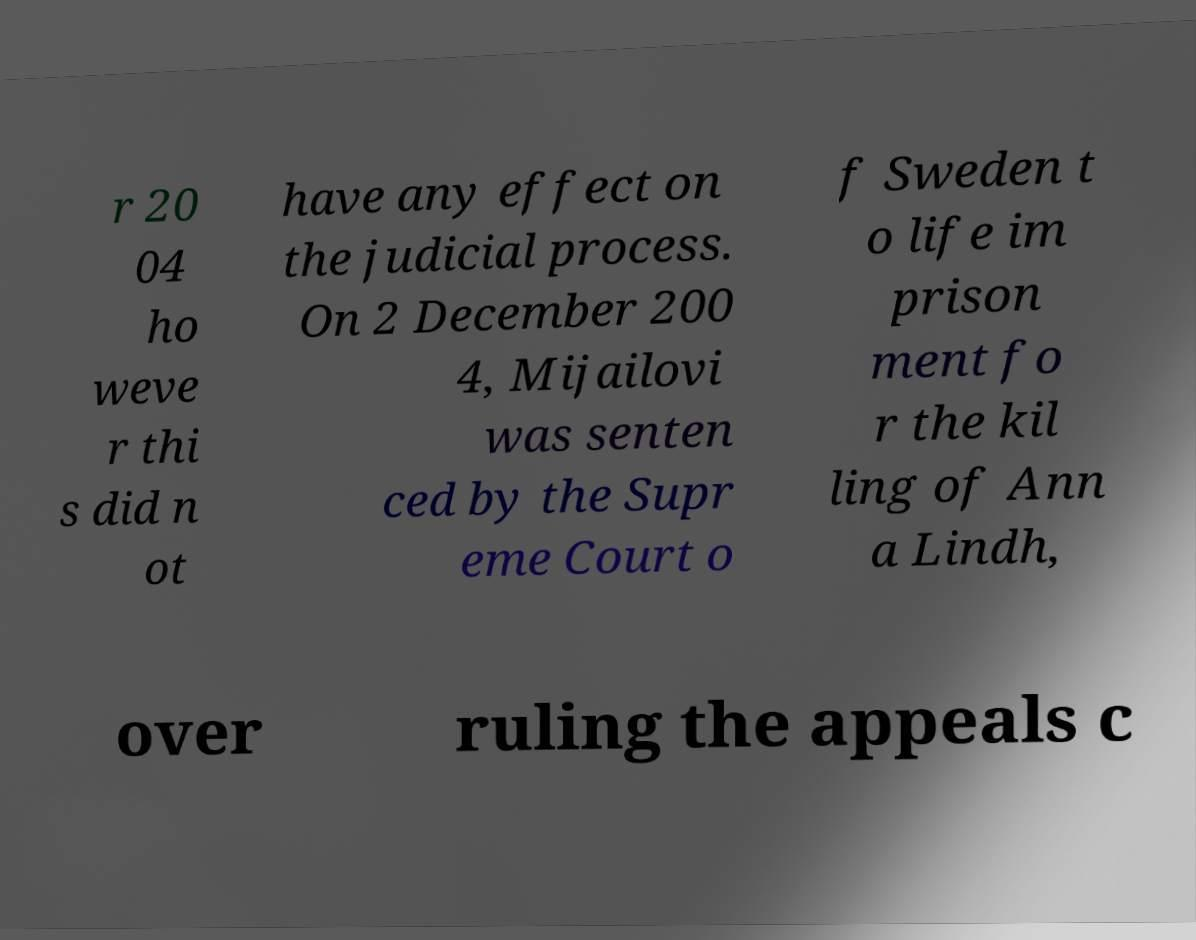There's text embedded in this image that I need extracted. Can you transcribe it verbatim? r 20 04 ho weve r thi s did n ot have any effect on the judicial process. On 2 December 200 4, Mijailovi was senten ced by the Supr eme Court o f Sweden t o life im prison ment fo r the kil ling of Ann a Lindh, over ruling the appeals c 